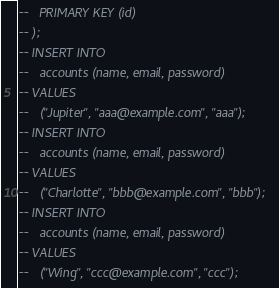<code> <loc_0><loc_0><loc_500><loc_500><_SQL_>--   PRIMARY KEY (id)
-- );
-- INSERT INTO
--   accounts (name, email, password)
-- VALUES
--   ("Jupiter", "aaa@example.com", "aaa");
-- INSERT INTO
--   accounts (name, email, password)
-- VALUES
--   ("Charlotte", "bbb@example.com", "bbb");
-- INSERT INTO
--   accounts (name, email, password)
-- VALUES
--   ("Wing", "ccc@example.com", "ccc");</code> 